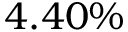Convert formula to latex. <formula><loc_0><loc_0><loc_500><loc_500>4 . 4 0 \%</formula> 